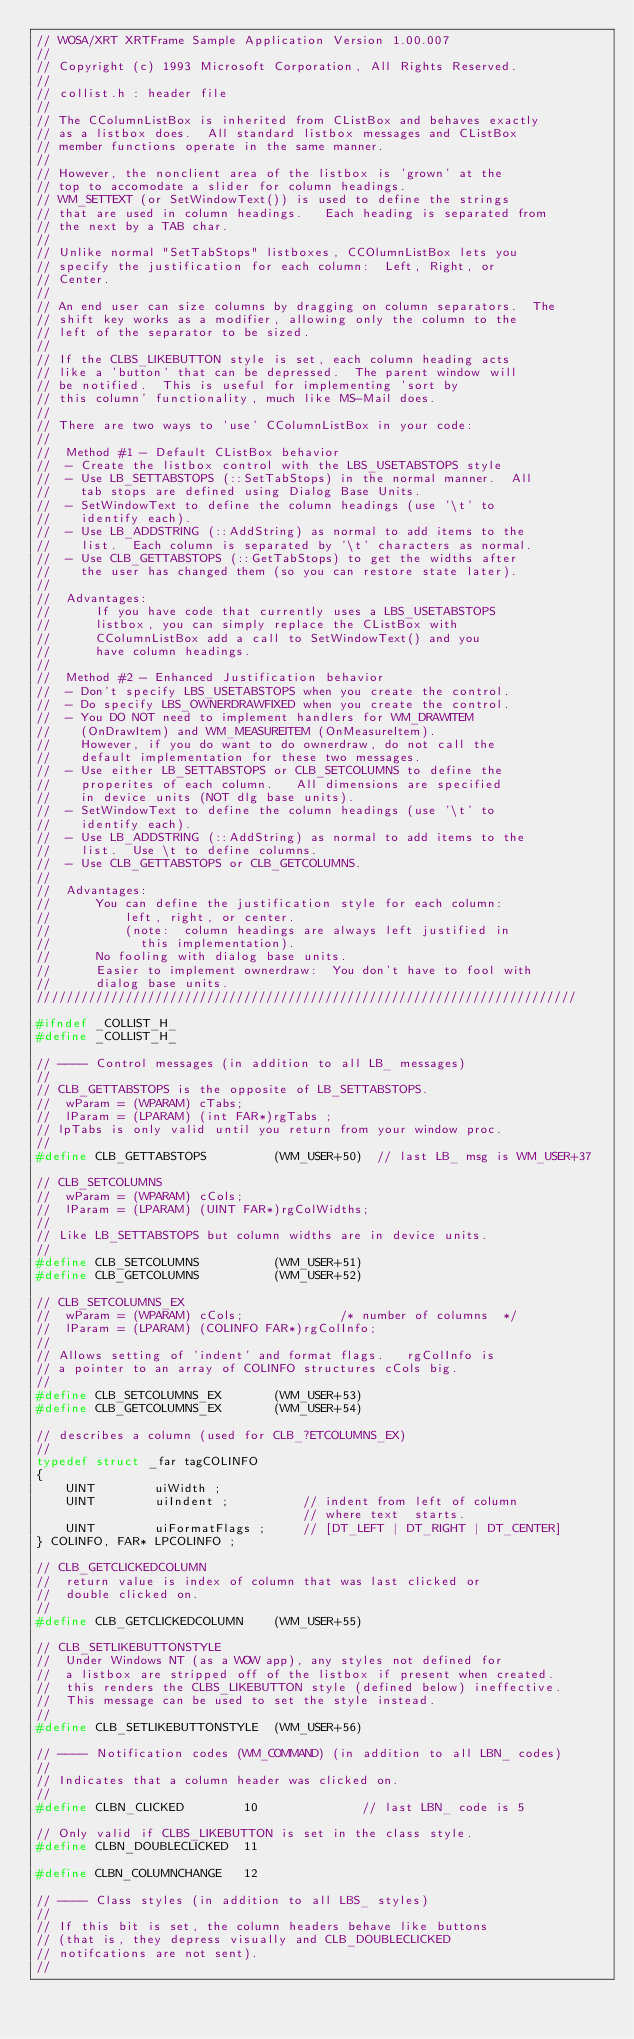<code> <loc_0><loc_0><loc_500><loc_500><_C_>// WOSA/XRT XRTFrame Sample Application Version 1.00.007
//
// Copyright (c) 1993 Microsoft Corporation, All Rights Reserved.
//
// collist.h : header file
//
// The CColumnListBox is inherited from CListBox and behaves exactly
// as a listbox does.  All standard listbox messages and CListBox
// member functions operate in the same manner.
//
// However, the nonclient area of the listbox is 'grown' at the
// top to accomodate a slider for column headings.  
// WM_SETTEXT (or SetWindowText()) is used to define the strings
// that are used in column headings.   Each heading is separated from
// the next by a TAB char.
//
// Unlike normal "SetTabStops" listboxes, CCOlumnListBox lets you
// specify the justification for each column:  Left, Right, or 
// Center.
//
// An end user can size columns by dragging on column separators.  The
// shift key works as a modifier, allowing only the column to the
// left of the separator to be sized.
//
// If the CLBS_LIKEBUTTON style is set, each column heading acts
// like a 'button' that can be depressed.  The parent window will
// be notified.  This is useful for implementing 'sort by
// this column' functionality, much like MS-Mail does.
//
// There are two ways to 'use' CColumnListBox in your code:
//
//  Method #1 - Default CListBox behavior      
//  - Create the listbox control with the LBS_USETABSTOPS style
//  - Use LB_SETTABSTOPS (::SetTabStops) in the normal manner.  All
//    tab stops are defined using Dialog Base Units.
//  - SetWindowText to define the column headings (use '\t' to 
//    identify each).
//  - Use LB_ADDSTRING (::AddString) as normal to add items to the
//    list.  Each column is separated by '\t' characters as normal.
//  - Use CLB_GETTABSTOPS (::GetTabStops) to get the widths after
//    the user has changed them (so you can restore state later).
//
//  Advantages:
//      If you have code that currently uses a LBS_USETABSTOPS 
//      listbox, you can simply replace the CListBox with 
//      CColumnListBox add a call to SetWindowText() and you 
//      have column headings.
//      
//  Method #2 - Enhanced Justification behavior
//  - Don't specify LBS_USETABSTOPS when you create the control.
//  - Do specify LBS_OWNERDRAWFIXED when you create the control.
//  - You DO NOT need to implement handlers for WM_DRAWITEM 
//    (OnDrawItem) and WM_MEASUREITEM (OnMeasureItem).  
//    However, if you do want to do ownerdraw, do not call the
//    default implementation for these two messages.
//  - Use either LB_SETTABSTOPS or CLB_SETCOLUMNS to define the
//    properites of each column.   All dimensions are specified 
//    in device units (NOT dlg base units).
//  - SetWindowText to define the column headings (use '\t' to 
//    identify each).
//  - Use LB_ADDSTRING (::AddString) as normal to add items to the
//    list.  Use \t to define columns.
//  - Use CLB_GETTABSTOPS or CLB_GETCOLUMNS.
//  
//  Advantages:
//      You can define the justification style for each column:
//          left, right, or center.
//          (note:  column headings are always left justified in
//            this implementation).
//      No fooling with dialog base units.
//      Easier to implement ownerdraw:  You don't have to fool with
//      dialog base units.
/////////////////////////////////////////////////////////////////////////

#ifndef _COLLIST_H_
#define _COLLIST_H_

// ---- Control messages (in addition to all LB_ messages)
// 
// CLB_GETTABSTOPS is the opposite of LB_SETTABSTOPS. 
//  wParam = (WPARAM) cTabs;             
//  lParam = (LPARAM) (int FAR*)rgTabs ; 
// lpTabs is only valid until you return from your window proc.
//
#define CLB_GETTABSTOPS         (WM_USER+50)  // last LB_ msg is WM_USER+37

// CLB_SETCOLUMNS
//  wParam = (WPARAM) cCols;             
//  lParam = (LPARAM) (UINT FAR*)rgColWidths; 
//
// Like LB_SETTABSTOPS but column widths are in device units.
//  
#define CLB_SETCOLUMNS          (WM_USER+51)
#define CLB_GETCOLUMNS          (WM_USER+52)

// CLB_SETCOLUMNS_EX
//  wParam = (WPARAM) cCols;             /* number of columns  */
//  lParam = (LPARAM) (COLINFO FAR*)rgColInfo; 
//
// Allows setting of 'indent' and format flags.   rgColInfo is
// a pointer to an array of COLINFO structures cCols big.
//  
#define CLB_SETCOLUMNS_EX       (WM_USER+53)
#define CLB_GETCOLUMNS_EX       (WM_USER+54)

// describes a column (used for CLB_?ETCOLUMNS_EX)
//
typedef struct _far tagCOLINFO
{
    UINT        uiWidth ;
    UINT        uiIndent ;          // indent from left of column 
                                    // where text  starts.  
    UINT        uiFormatFlags ;     // [DT_LEFT | DT_RIGHT | DT_CENTER]
} COLINFO, FAR* LPCOLINFO ;
                                            
// CLB_GETCLICKEDCOLUMN                                            
//  return value is index of column that was last clicked or
//  double clicked on.
//
#define CLB_GETCLICKEDCOLUMN    (WM_USER+55)

// CLB_SETLIKEBUTTONSTYLE
//  Under Windows NT (as a WOW app), any styles not defined for 
//  a listbox are stripped off of the listbox if present when created.
//  this renders the CLBS_LIKEBUTTON style (defined below) ineffective.
//  This message can be used to set the style instead.
//
#define CLB_SETLIKEBUTTONSTYLE  (WM_USER+56)

// ---- Notification codes (WM_COMMAND) (in addition to all LBN_ codes)
//
// Indicates that a column header was clicked on.
//
#define CLBN_CLICKED        10              // last LBN_ code is 5

// Only valid if CLBS_LIKEBUTTON is set in the class style.
#define CLBN_DOUBLECLICKED  11

#define CLBN_COLUMNCHANGE   12

// ---- Class styles (in addition to all LBS_ styles)
// 
// If this bit is set, the column headers behave like buttons
// (that is, they depress visually and CLB_DOUBLECLICKED 
// notifcations are not sent).
//</code> 